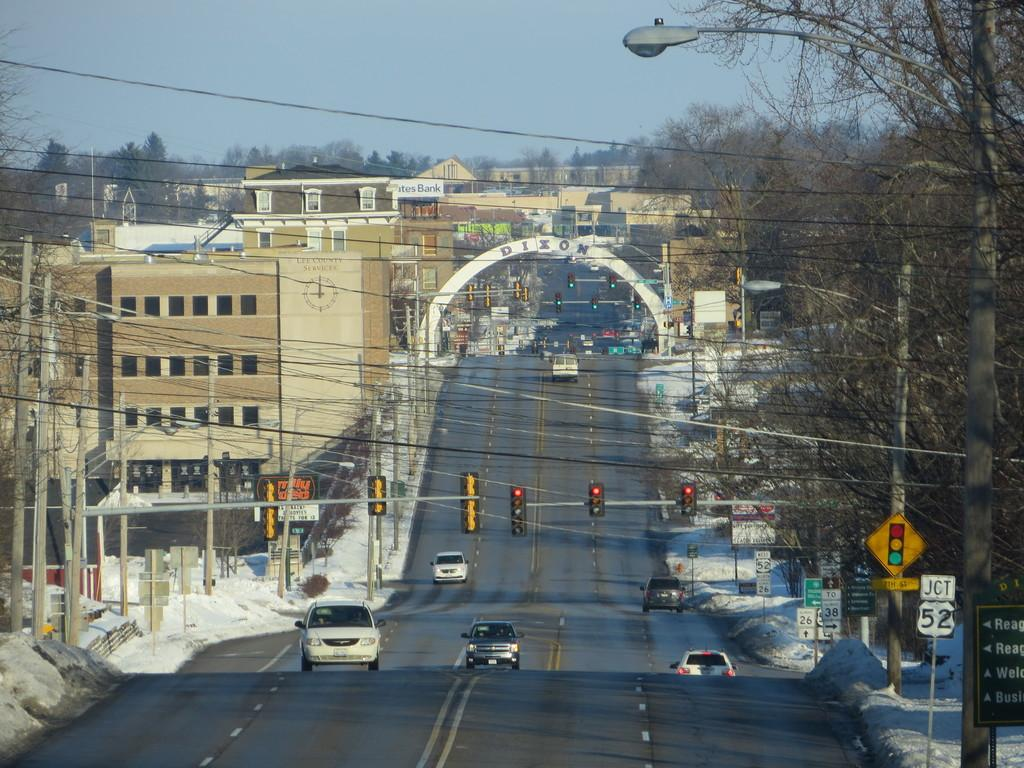What can be seen running through the image, connecting various elements? There are wires in the image. What structures are present in the image that support the wires? There are poles in the image. What type of information or advertisements are displayed in the image? There are signboards in the image. What devices are present in the image to control traffic flow? There are signal lights in the image. What type of natural elements can be seen in the image? There are trees in the image. What type of man-made structures are present in the image? There are buildings in the image. What type of transportation can be seen on the road in the image? There are vehicles on the road in the image. What is visible at the top of the image? The sky is visible at the top of the image, and there is a light visible as well. Where is the crown located in the image? There is no crown present in the image. What type of grain can be seen growing in the image? There is no grain present in the image. Is there a baby visible in the image? There is no baby present in the image. 